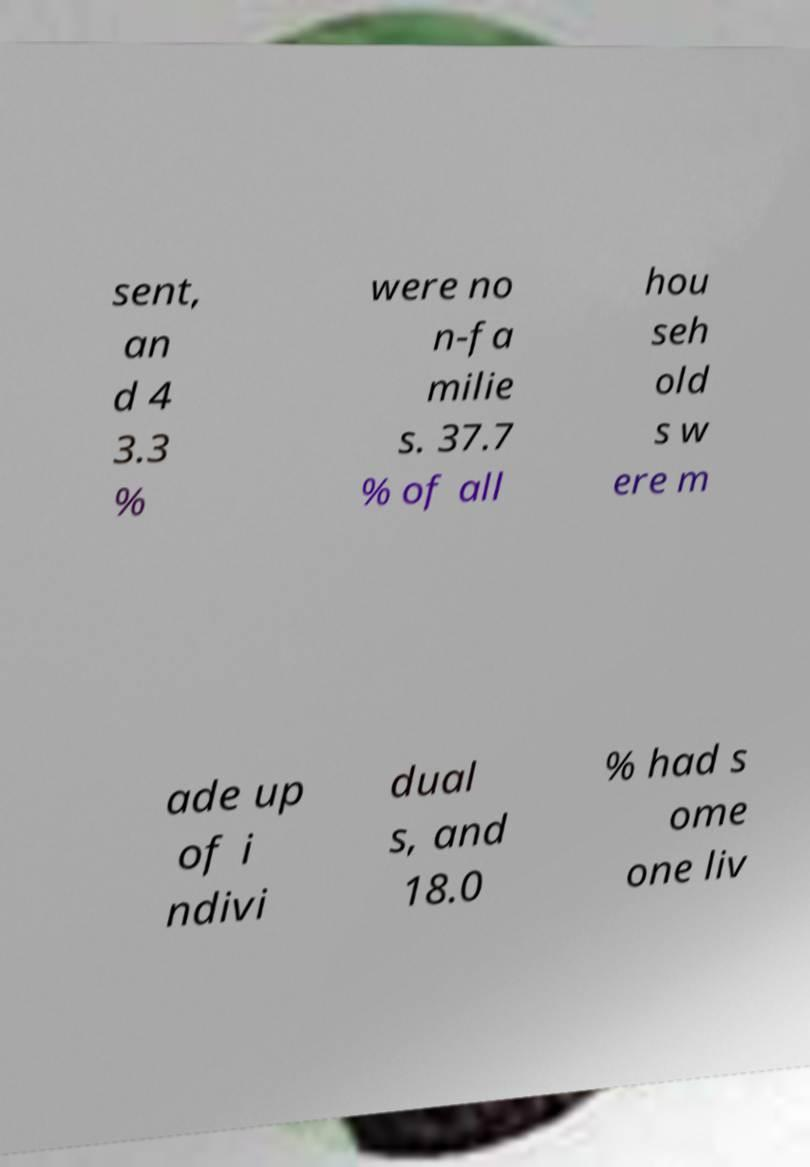I need the written content from this picture converted into text. Can you do that? sent, an d 4 3.3 % were no n-fa milie s. 37.7 % of all hou seh old s w ere m ade up of i ndivi dual s, and 18.0 % had s ome one liv 